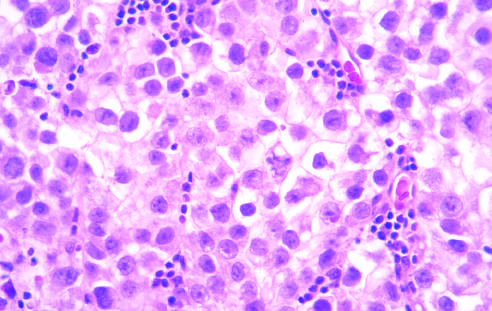how does microscopic examination reveal large cells?
Answer the question using a single word or phrase. With distinct borders 